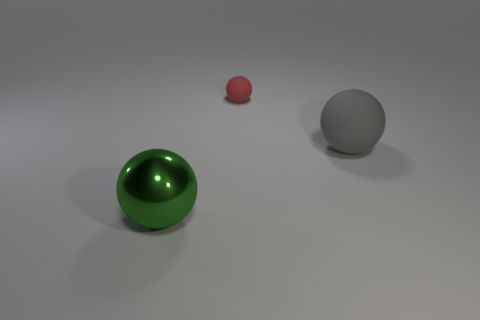Add 2 cyan rubber cylinders. How many objects exist? 5 Subtract 0 purple cubes. How many objects are left? 3 Subtract all small red cylinders. Subtract all green objects. How many objects are left? 2 Add 1 large metallic balls. How many large metallic balls are left? 2 Add 1 blue cubes. How many blue cubes exist? 1 